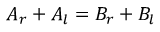Convert formula to latex. <formula><loc_0><loc_0><loc_500><loc_500>A _ { r } + A _ { l } = B _ { r } + B _ { l }</formula> 